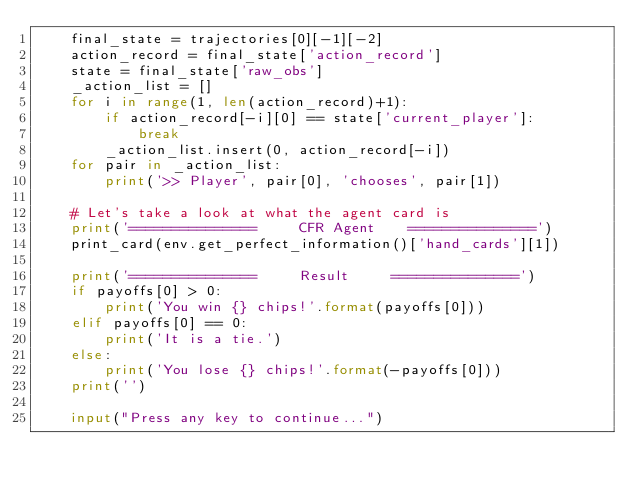<code> <loc_0><loc_0><loc_500><loc_500><_Python_>    final_state = trajectories[0][-1][-2]
    action_record = final_state['action_record']
    state = final_state['raw_obs']
    _action_list = []
    for i in range(1, len(action_record)+1):
        if action_record[-i][0] == state['current_player']:
            break
        _action_list.insert(0, action_record[-i])
    for pair in _action_list:
        print('>> Player', pair[0], 'chooses', pair[1])

    # Let's take a look at what the agent card is
    print('===============     CFR Agent    ===============')
    print_card(env.get_perfect_information()['hand_cards'][1])

    print('===============     Result     ===============')
    if payoffs[0] > 0:
        print('You win {} chips!'.format(payoffs[0]))
    elif payoffs[0] == 0:
        print('It is a tie.')
    else:
        print('You lose {} chips!'.format(-payoffs[0]))
    print('')

    input("Press any key to continue...")
</code> 